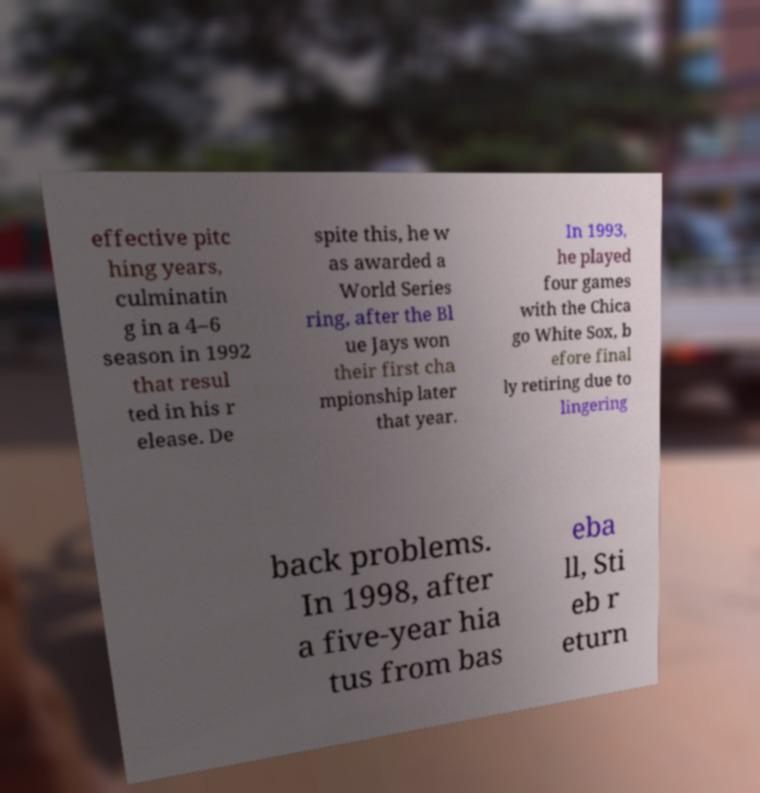Could you extract and type out the text from this image? effective pitc hing years, culminatin g in a 4–6 season in 1992 that resul ted in his r elease. De spite this, he w as awarded a World Series ring, after the Bl ue Jays won their first cha mpionship later that year. In 1993, he played four games with the Chica go White Sox, b efore final ly retiring due to lingering back problems. In 1998, after a five-year hia tus from bas eba ll, Sti eb r eturn 